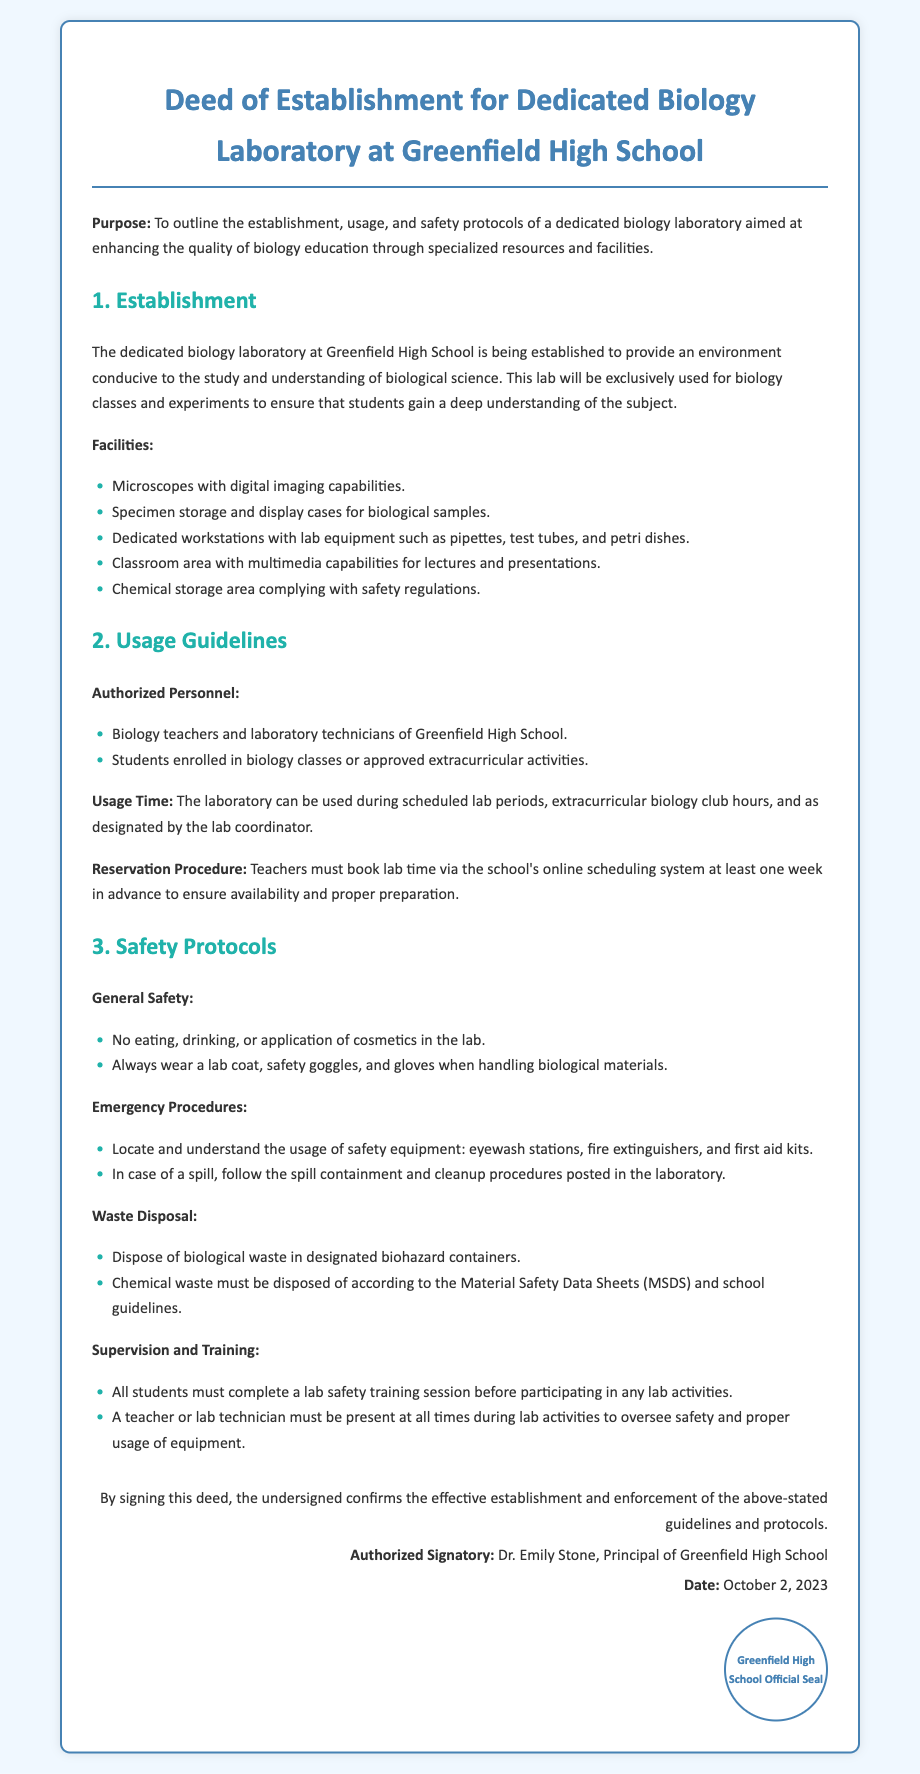What is the purpose of the deed? The purpose outlined in the deed is to enhance the quality of biology education through specialized resources and facilities.
Answer: To outline the establishment, usage, and safety protocols of a dedicated biology laboratory aimed at enhancing the quality of biology education through specialized resources and facilities When was the deed signed? The deed includes a date confirming when it was signed by the authorized signatory.
Answer: October 2, 2023 Who is the authorized signatory? The document specifies who has signed the deed and confirms its establishment.
Answer: Dr. Emily Stone What are the facilities mentioned in the laboratory? This queries the specific features included in the biology laboratory outlined in the deed.
Answer: Microscopes with digital imaging capabilities, Specimen storage and display cases, Dedicated workstations with lab equipment, Classroom area with multimedia capabilities, Chemical storage area What is required for students before participating in lab activities? The deed states the prerequisite for students to ensure safety before engaging in lab procedures.
Answer: Complete a lab safety training session Who is authorized to use the laboratory? This question pertains to the people permitted to access and use the facilities as stated in the document.
Answer: Biology teachers and laboratory technicians, Students enrolled in biology classes or approved extracurricular activities What must teachers do to reserve lab time? This question looks for the procedure that teachers need to follow regarding the scheduling of laboratory use.
Answer: Book lab time via the school's online scheduling system at least one week in advance What must be worn when handling biological materials? This question seeks specific safety equipment required during lab activities outlined in the safety protocols section.
Answer: Lab coat, safety goggles, and gloves 